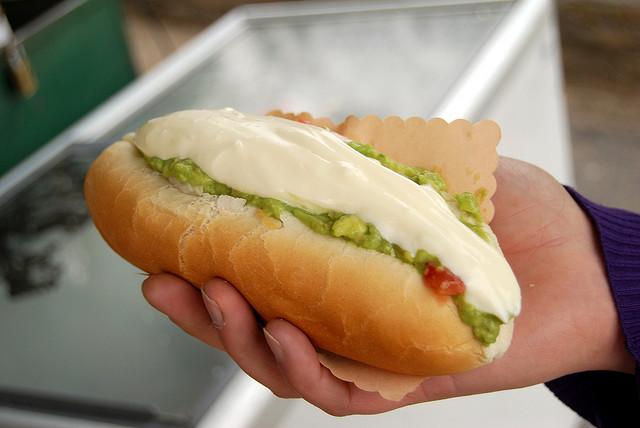Would you need yeast to create the outer shell of this food item?
Concise answer only. Yes. Is that a pickle on top?
Keep it brief. No. What hand is the man holding the hot dog with?
Concise answer only. Right. What  food is in the person's hand?
Keep it brief. Hot dog. Is there any mayonnaise on the sandwich?
Quick response, please. Yes. What condiments are on the hot dog?
Concise answer only. Mayo. 